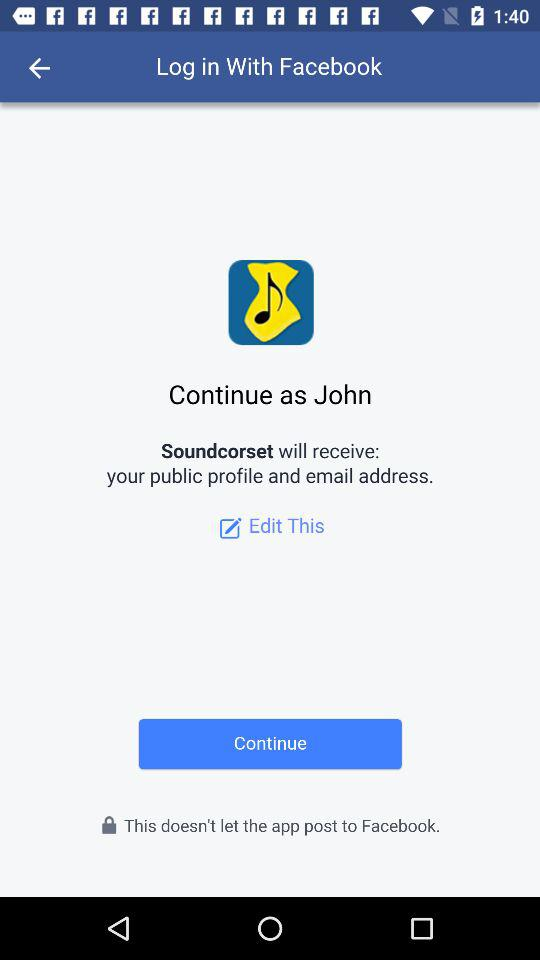How can we login? We can log in through Facebook. 